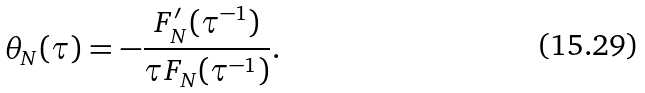<formula> <loc_0><loc_0><loc_500><loc_500>\theta _ { N } ( \tau ) = - \frac { F ^ { \prime } _ { N } ( \tau ^ { - 1 } ) } { \tau F _ { N } ( \tau ^ { - 1 } ) } .</formula> 